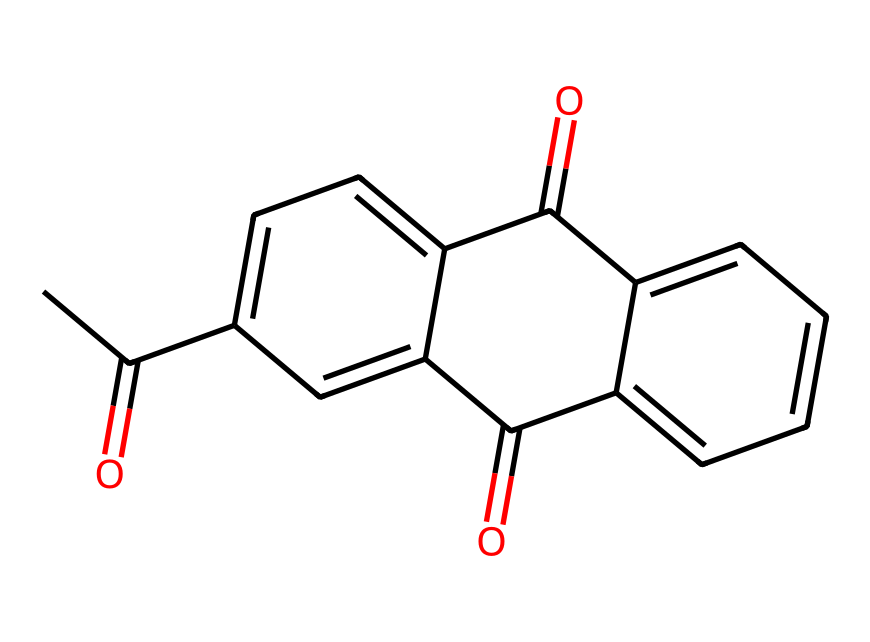What is the total number of carbon atoms in this chemical? By examining the SMILES representation, I can count the number of carbon atoms (C) present. The representation shows 15 carbon atoms.
Answer: 15 How many oxygen atoms are present in this molecule? From the SMILES, I can identify the oxygen atoms (O). The representation includes 4 oxygen atoms.
Answer: 4 What type of compound does this chemical represent? Upon analyzing the structure, it exhibits features typical of diketones due to the presence of two carbonyl groups (C=O).
Answer: diketone What is the degree of saturation of this chemical? The degree of saturation can be determined by considering the number of rings and multiple bonds. As this molecule contains multiple rings and no double bonds (other than carbonyls), it indicates it is fully saturated.
Answer: saturated Which functional group is indicated by the presence of C=O? The presence of the carbonyl (C=O) functional group points to the classification of this compound as a ketone.
Answer: ketone Does this chemical structure likely contain aromatic characteristics? The presence of alternating double bonds in rings suggests that this chemical structure displays aromatic characteristics.
Answer: yes How many rings are present in this chemical's structure? By closely examining the arrangement in the SMILES representation, I can see the structure includes 2 distinct rings.
Answer: 2 